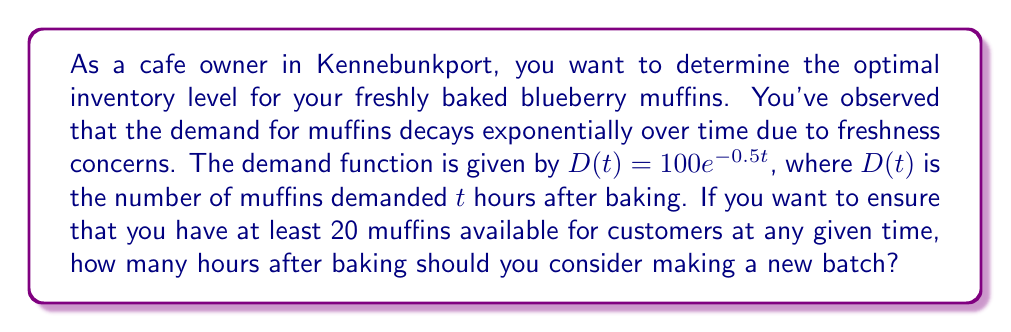Provide a solution to this math problem. To solve this problem, we need to use the given exponential demand function and find the time at which the demand reaches 20 muffins. Let's approach this step-by-step:

1) The demand function is given as:
   $D(t) = 100e^{-0.5t}$

2) We want to find $t$ when $D(t) = 20$. So, we set up the equation:
   $20 = 100e^{-0.5t}$

3) Divide both sides by 100:
   $\frac{20}{100} = e^{-0.5t}$
   $0.2 = e^{-0.5t}$

4) Take the natural logarithm of both sides:
   $\ln(0.2) = \ln(e^{-0.5t})$
   $\ln(0.2) = -0.5t$

5) Solve for $t$:
   $t = -\frac{\ln(0.2)}{0.5}$

6) Calculate the value:
   $t = -\frac{\ln(0.2)}{0.5} \approx 3.22$ hours

Therefore, approximately 3.22 hours after baking, the demand will drop to 20 muffins.
Answer: $t \approx 3.22$ hours 